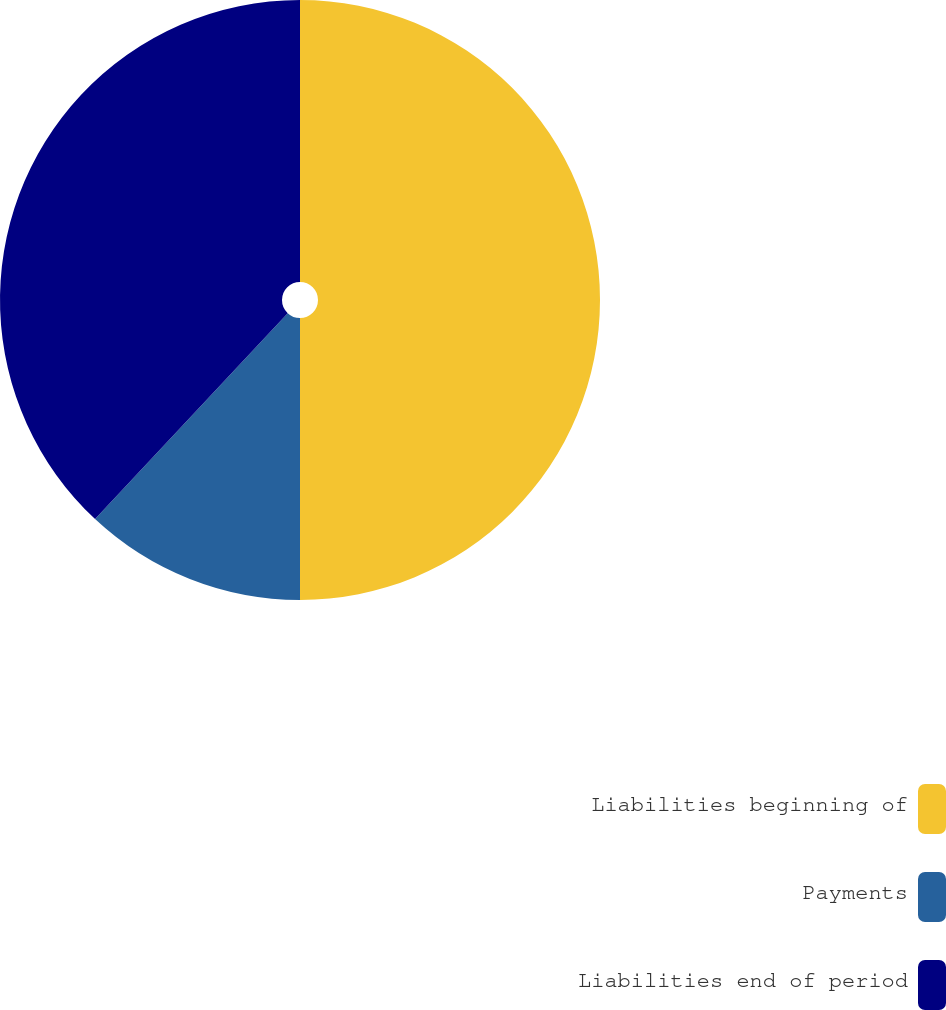Convert chart to OTSL. <chart><loc_0><loc_0><loc_500><loc_500><pie_chart><fcel>Liabilities beginning of<fcel>Payments<fcel>Liabilities end of period<nl><fcel>50.0%<fcel>11.97%<fcel>38.03%<nl></chart> 